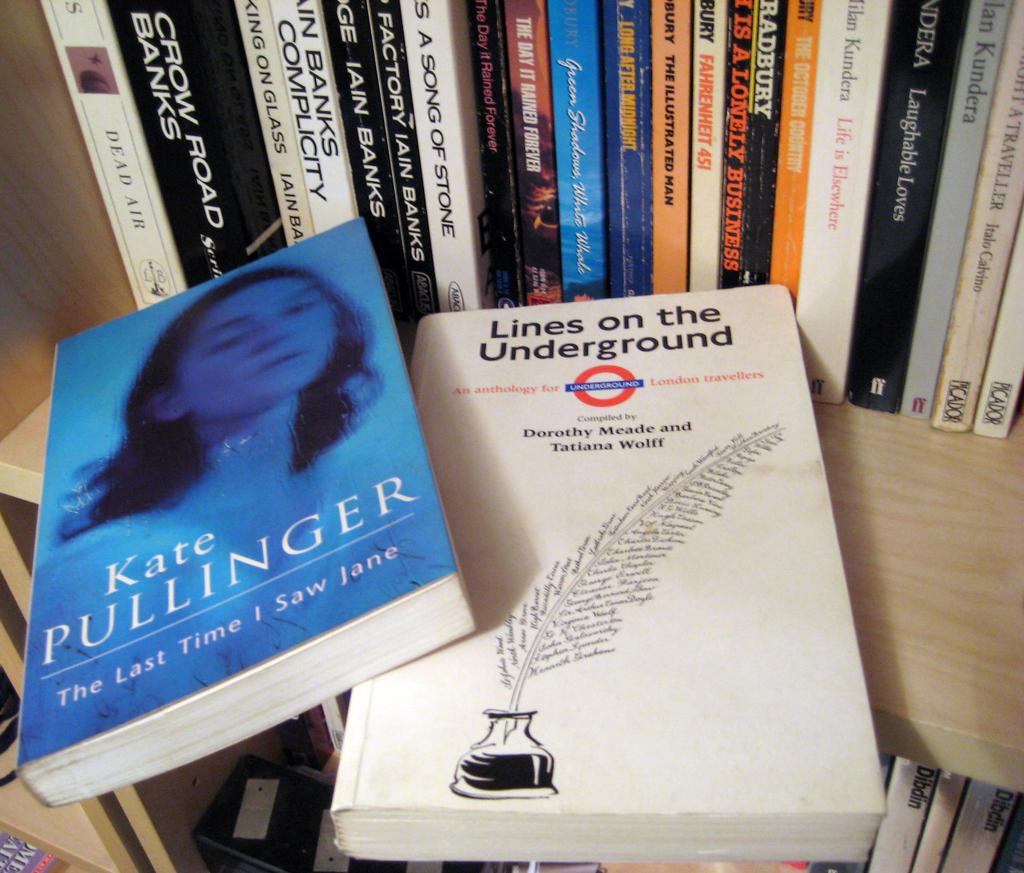Provide a one-sentence caption for the provided image. A shelf full of books with a book that is titles Lines on the Underground sitting up front. 